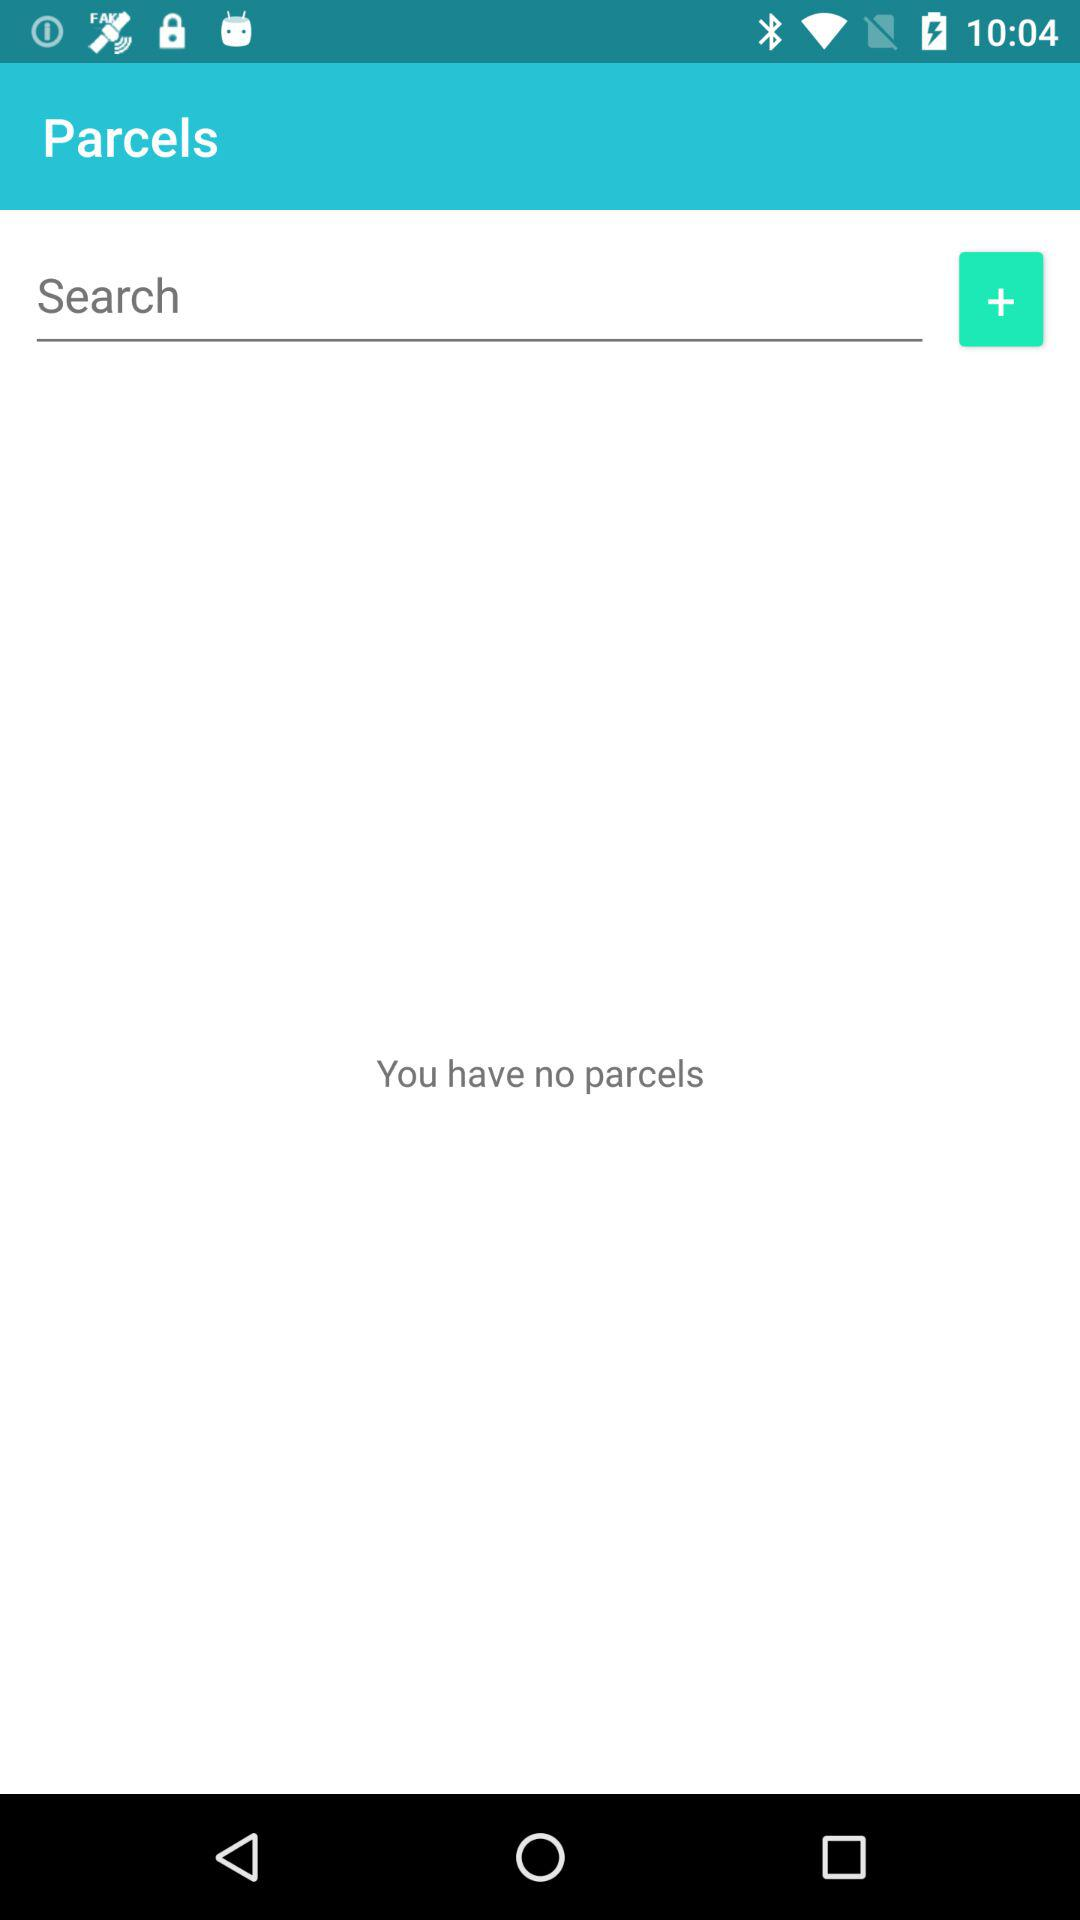How many parcels do I have?
Answer the question using a single word or phrase. 0 